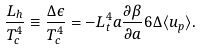Convert formula to latex. <formula><loc_0><loc_0><loc_500><loc_500>\frac { L _ { h } } { T ^ { 4 } _ { c } } \equiv \frac { \Delta \epsilon } { T ^ { 4 } _ { c } } = - L _ { t } ^ { 4 } a \frac { \partial \beta } { \partial a } 6 \Delta \langle u _ { p } \rangle .</formula> 